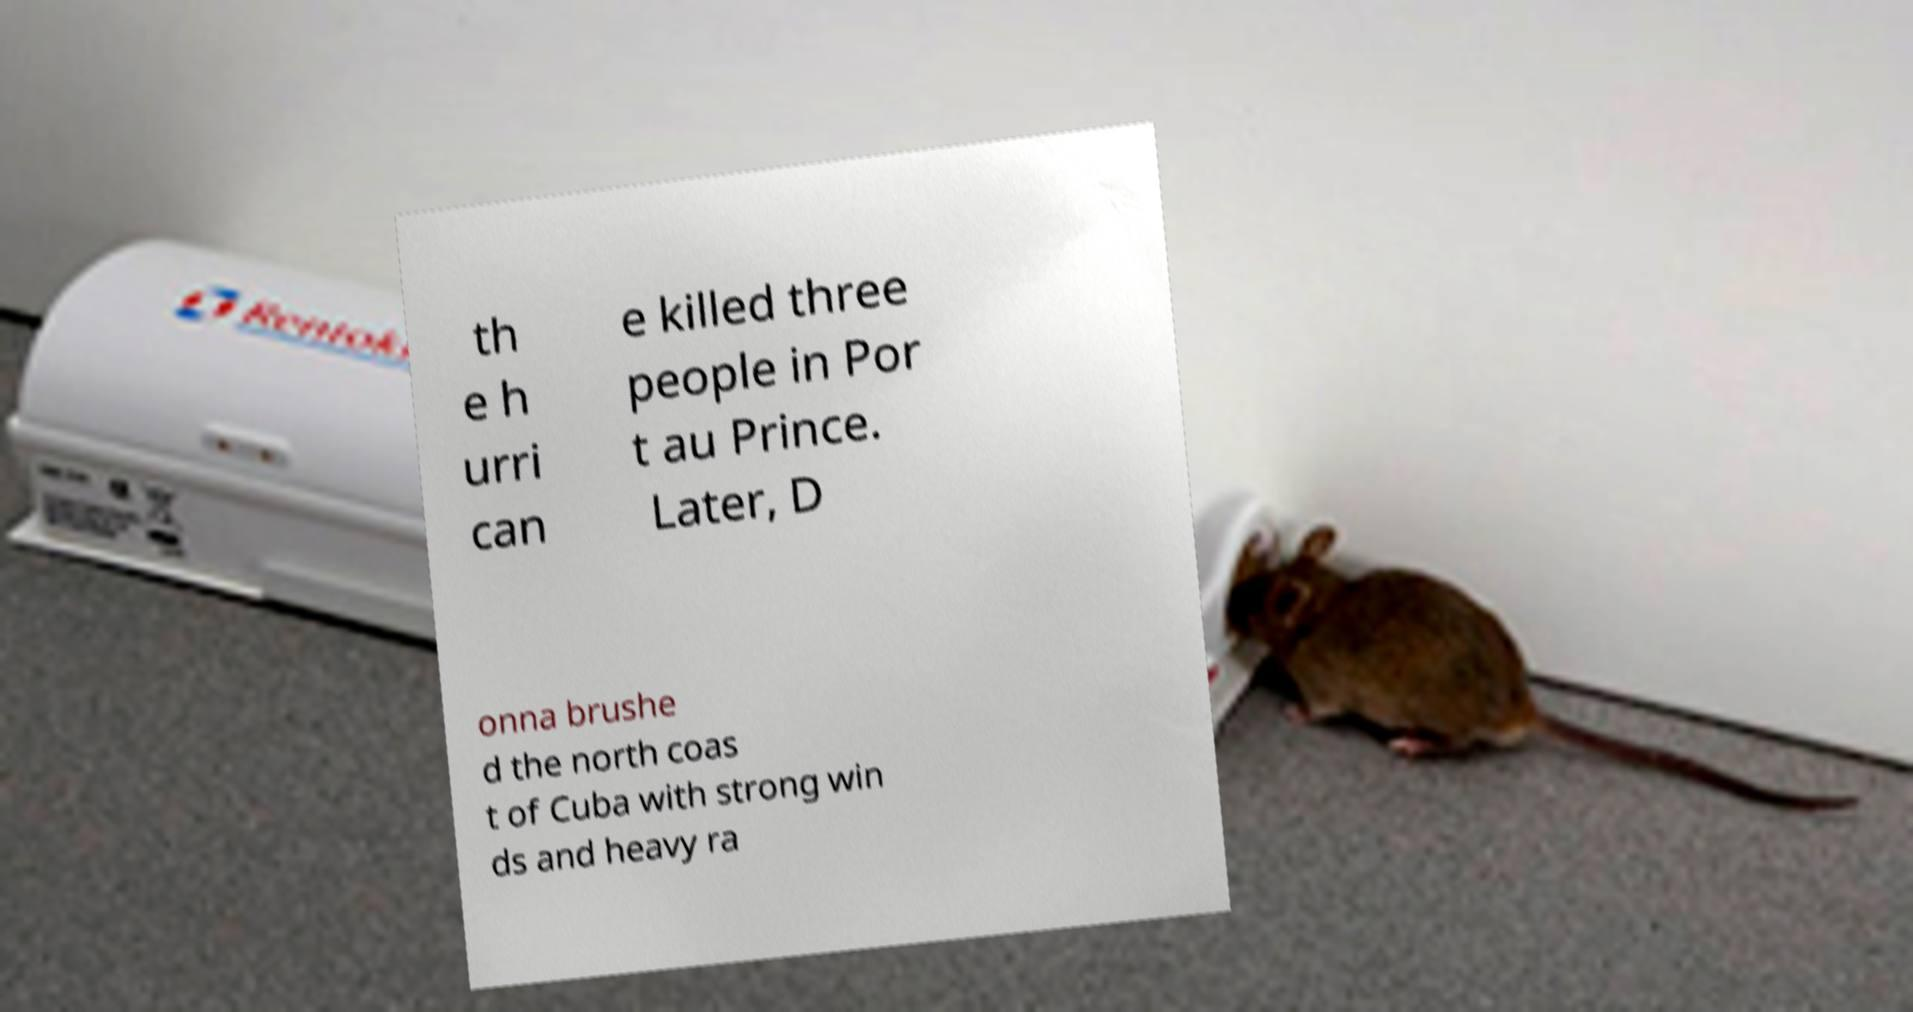Please identify and transcribe the text found in this image. th e h urri can e killed three people in Por t au Prince. Later, D onna brushe d the north coas t of Cuba with strong win ds and heavy ra 